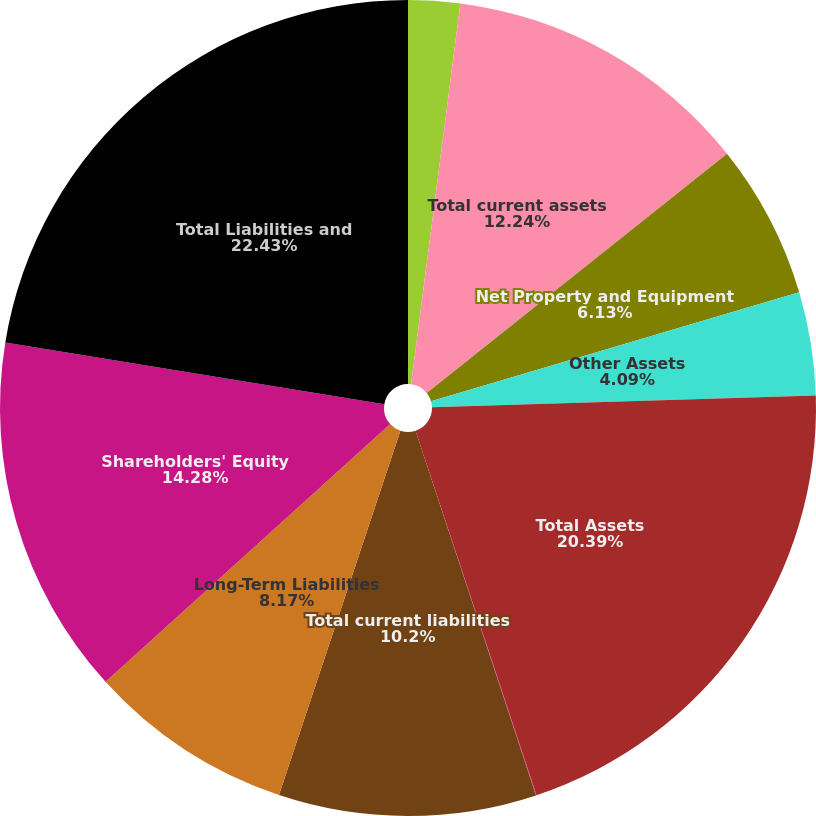Convert chart. <chart><loc_0><loc_0><loc_500><loc_500><pie_chart><fcel>Other current assets<fcel>Total current assets<fcel>Net Property and Equipment<fcel>Other Assets<fcel>Total Assets<fcel>Accrued liabilities<fcel>Total current liabilities<fcel>Long-Term Liabilities<fcel>Shareholders' Equity<fcel>Total Liabilities and<nl><fcel>2.05%<fcel>12.24%<fcel>6.13%<fcel>4.09%<fcel>20.39%<fcel>0.02%<fcel>10.2%<fcel>8.17%<fcel>14.28%<fcel>22.43%<nl></chart> 